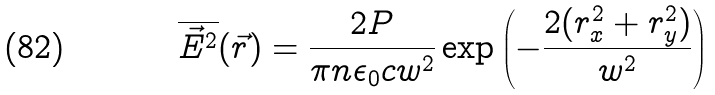<formula> <loc_0><loc_0><loc_500><loc_500>\overline { \vec { E } ^ { 2 } } ( \vec { r } ) = \frac { 2 P } { \pi n \epsilon _ { 0 } c w ^ { 2 } } \exp \left ( - \frac { 2 ( r _ { x } ^ { 2 } + r _ { y } ^ { 2 } ) } { w ^ { 2 } } \right )</formula> 